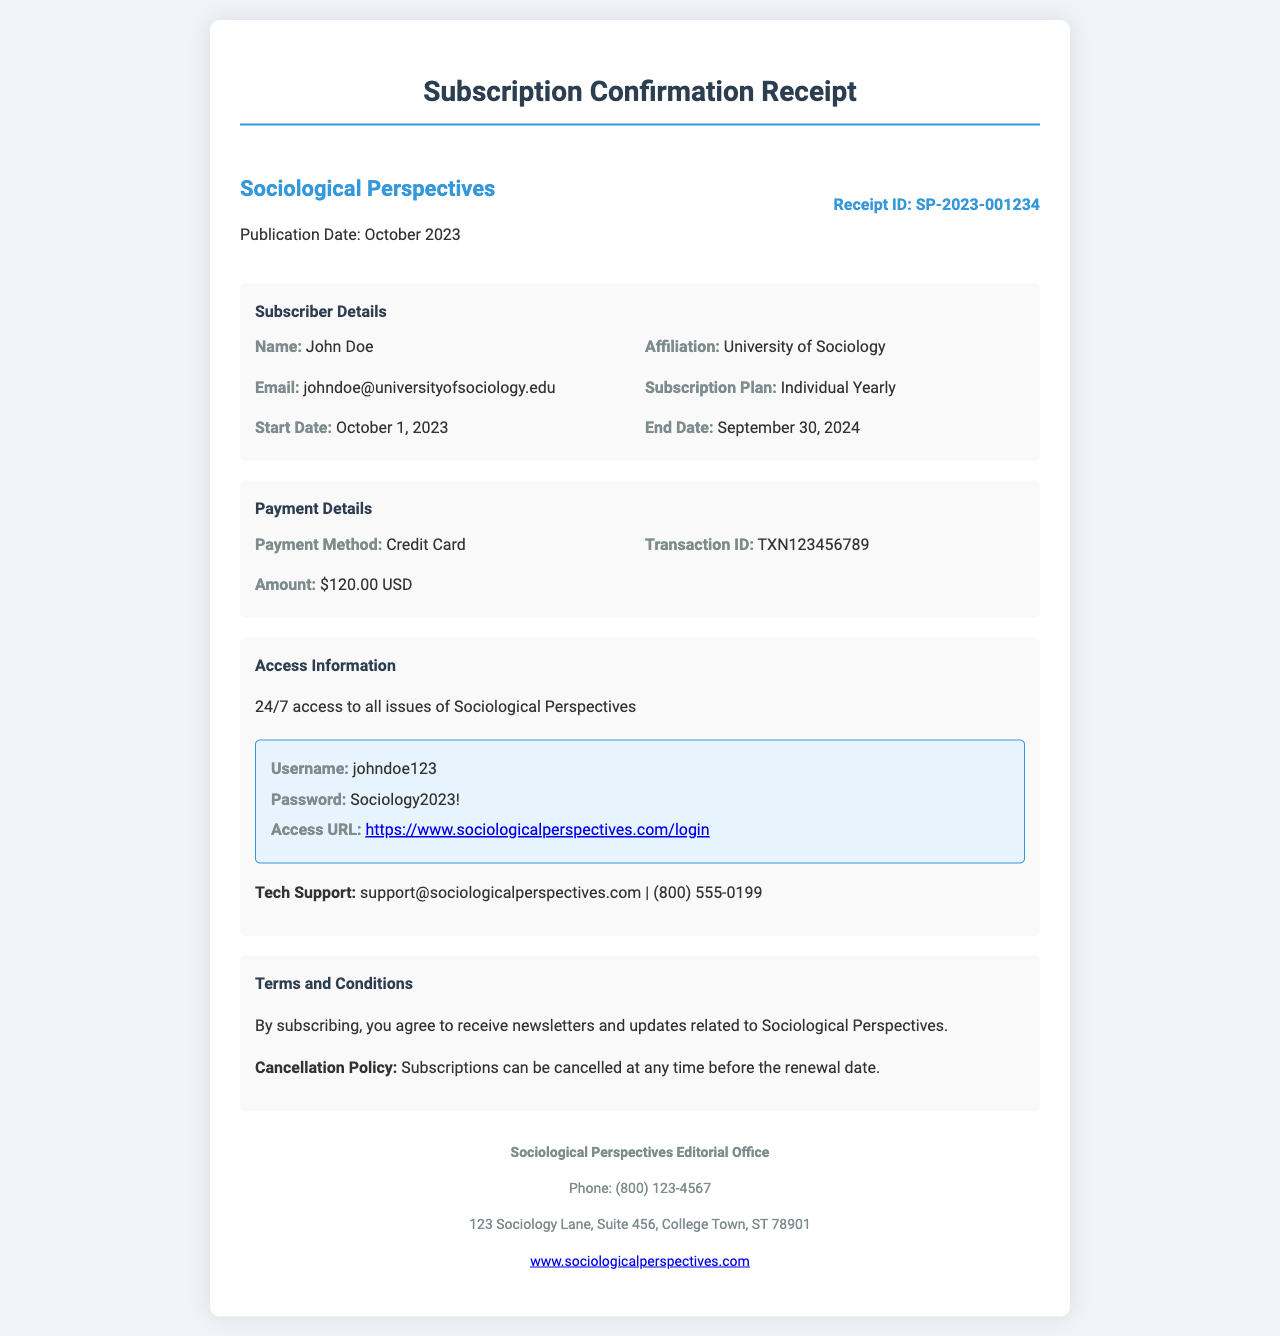What is the publication date? The publication date is located in the document and is stated clearly under the journal title.
Answer: October 2023 What is the Receipt ID? The Receipt ID is a specific identifier for this subscription, mentioned in the receipt header.
Answer: SP-2023-001234 What is the subscription plan? The subscription plan is detailed in the subscriber section of the document.
Answer: Individual Yearly What is the transaction ID? The transaction ID is part of the payment details provided in the document.
Answer: TXN123456789 What is the access URL? The access URL for digital content access is mentioned specifically in the access information section.
Answer: https://www.sociologicalperspectives.com/login How long is the subscription valid? The duration of the subscription can be inferred from the start and end dates provided in the subscriber details.
Answer: 1 year What is the cancellation policy? The policy regarding cancellation is stated in the terms and conditions section of the document.
Answer: Subscriptions can be cancelled at any time before the renewal date What type of support is available? The document mentions tech support contact details under the access information section.
Answer: Tech Support Who is the subscriber? The name of the subscriber is provided in the subscriber details section.
Answer: John Doe What is the payment amount? The total amount paid is specified in the payment details section of the document.
Answer: $120.00 USD 